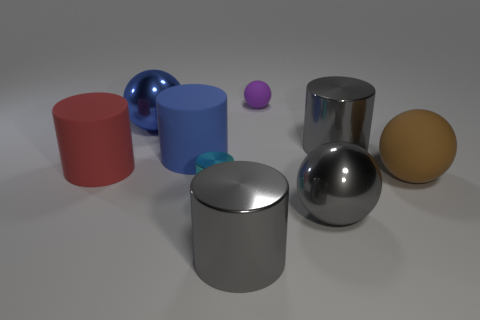Is the color of the tiny rubber sphere the same as the small metal cylinder?
Offer a terse response. No. There is a large gray cylinder behind the big red cylinder; what is its material?
Offer a terse response. Metal. What number of small things are blue matte balls or gray metallic things?
Give a very brief answer. 0. Is there a red cylinder made of the same material as the tiny cyan cylinder?
Your response must be concise. No. There is a cylinder to the right of the purple sphere; does it have the same size as the blue metal ball?
Your answer should be compact. Yes. There is a metallic cylinder that is on the right side of the metallic ball that is in front of the tiny cyan thing; are there any big gray balls on the right side of it?
Ensure brevity in your answer.  No. How many rubber things are either tiny red balls or large gray balls?
Provide a short and direct response. 0. What number of other objects are the same shape as the cyan metal thing?
Your answer should be very brief. 4. Are there more gray cylinders than small spheres?
Make the answer very short. Yes. There is a object that is in front of the large sphere in front of the small object that is in front of the purple sphere; what size is it?
Make the answer very short. Large. 